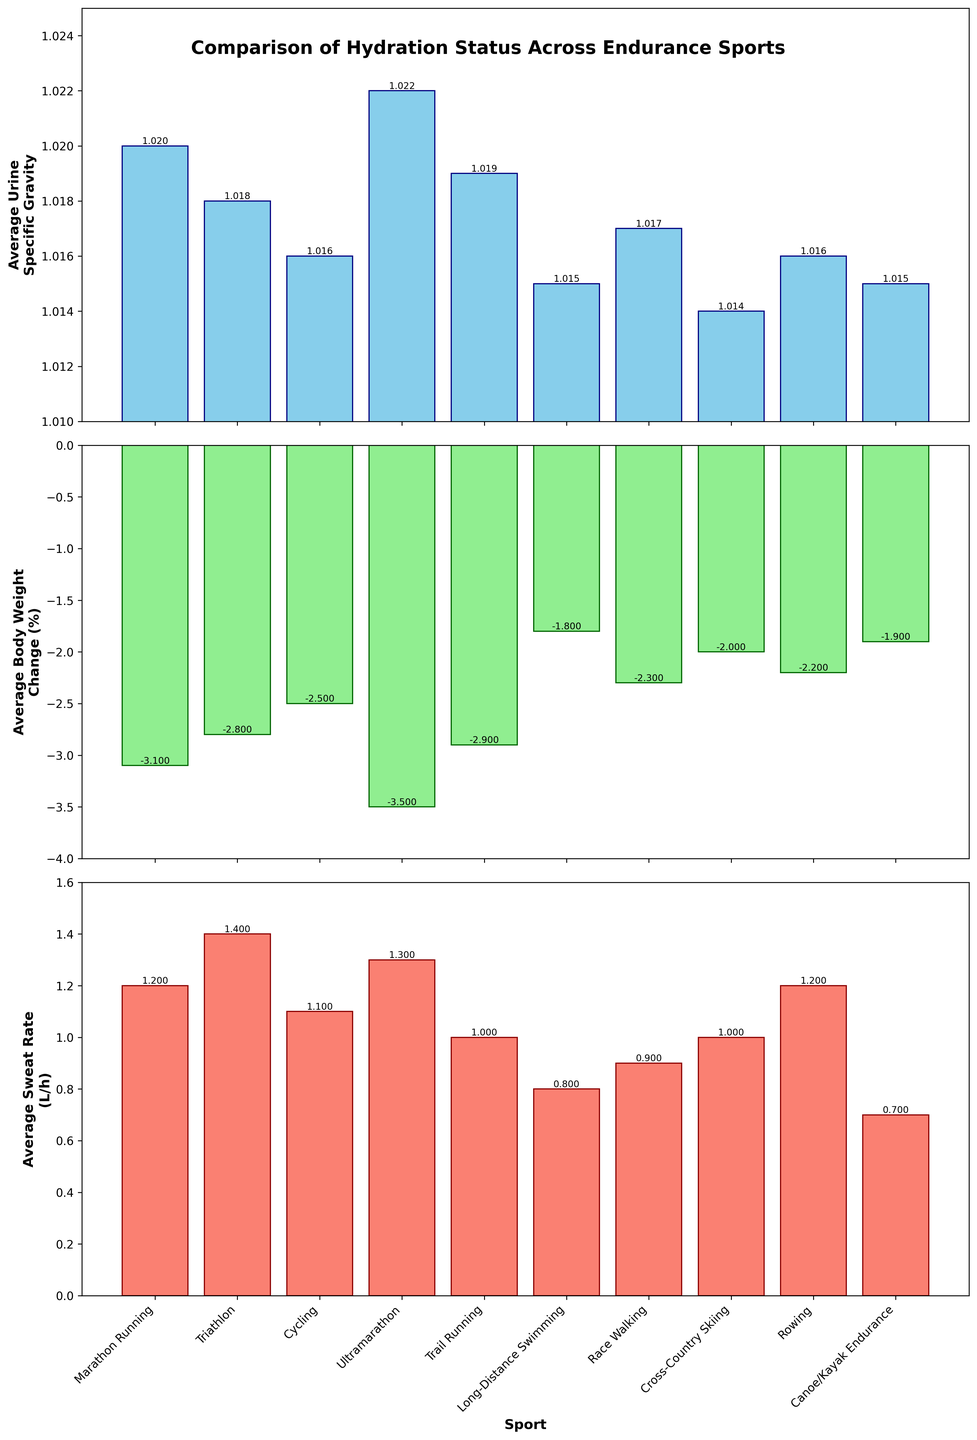Which sport has the highest average urine specific gravity? The average urine specific gravity is highest for the sport where the bar's height is the tallest in the first subplot. Ultramarathon is shown to have the highest bar in the first subplot.
Answer: Ultramarathon What is the difference in average body weight change between marathon running and long-distance swimming? First, find the average body weight change for marathon running (-3.1%) and long-distance swimming (-1.8%) from the second subplot. Subtract the latter from the former: -3.1 - (-1.8) = -3.1 + 1.8 = -1.3.
Answer: -1.3% Which sport shows the highest average sweat rate? The average sweat rate is indicated by the tallest bar in the third subplot. Triathlon shows the highest bar in the third subplot.
Answer: Triathlon Which sport has a lower average body weight change, rowing or trail running? Compare the bars of rowing and trail running in the second subplot. Trail running has a slightly higher bar (less negative), indicating less average body weight change than rowing.
Answer: Trail running What is the average urine specific gravity for all sports combined? Add up the urine specific gravity values for all sports, then divide by the number of sports. (1.020 + 1.018 + 1.016 + 1.022 + 1.019 + 1.015 + 1.017 + 1.014 + 1.016 + 1.015) / 10 = 1.0172.
Answer: 1.017 Which sport has the smallest average sweat rate, and what is its value? The smallest average sweat rate is identified by the shortest bar in the third subplot. Canoe/Kayak Endurance shows the shortest bar with a value of 0.7 L/h.
Answer: Canoe/Kayak Endurance, 0.7 L/h How does the average body weight change of cross-country skiing compare to that of marathon running? Compare the bar heights for cross-country skiing and marathon running in the second subplot. Marathon running shows a more negative (lower) body weight change than cross-country skiing.
Answer: Marathon running is lower What is the combined average sweat rate for cycling and rowing? Look at the bars for cycling and rowing in the third subplot, both have values of 1.1 L/h and 1.2 L/h respectively. Sum these two values: 1.1 + 1.2 = 2.3.
Answer: 2.3 L/h Which sport has the least change in average body weight percentage? The least body weight percentage change is indicated by the least negative bar in the second subplot. Long-Distance Swimming shows the least negative bar at -1.8%.
Answer: Long-Distance Swimming What's the difference between the highest and the lowest average urine specific gravity values? The highest average urine specific gravity is from Ultramarathon (1.022) and the lowest is from Cross-Country Skiing (1.014). Subtract the lowest from the highest: 1.022 - 1.014 = 0.008.
Answer: 0.008 